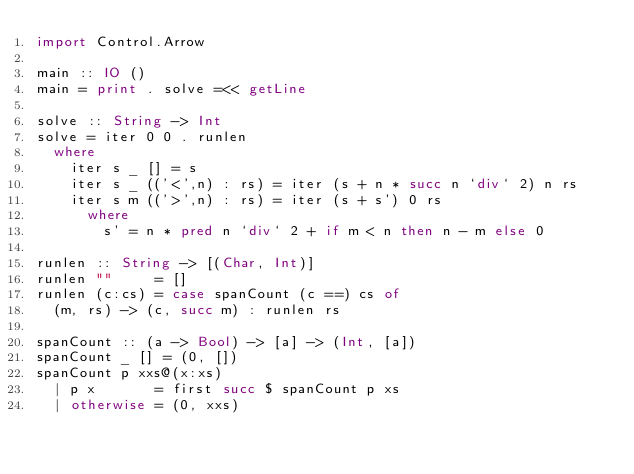Convert code to text. <code><loc_0><loc_0><loc_500><loc_500><_Haskell_>import Control.Arrow

main :: IO ()
main = print . solve =<< getLine

solve :: String -> Int
solve = iter 0 0 . runlen
  where
    iter s _ [] = s
    iter s _ (('<',n) : rs) = iter (s + n * succ n `div` 2) n rs
    iter s m (('>',n) : rs) = iter (s + s') 0 rs
      where
        s' = n * pred n `div` 2 + if m < n then n - m else 0
        
runlen :: String -> [(Char, Int)]
runlen ""     = []
runlen (c:cs) = case spanCount (c ==) cs of
  (m, rs) -> (c, succ m) : runlen rs

spanCount :: (a -> Bool) -> [a] -> (Int, [a])
spanCount _ [] = (0, [])
spanCount p xxs@(x:xs) 
  | p x       = first succ $ spanCount p xs
  | otherwise = (0, xxs)
</code> 